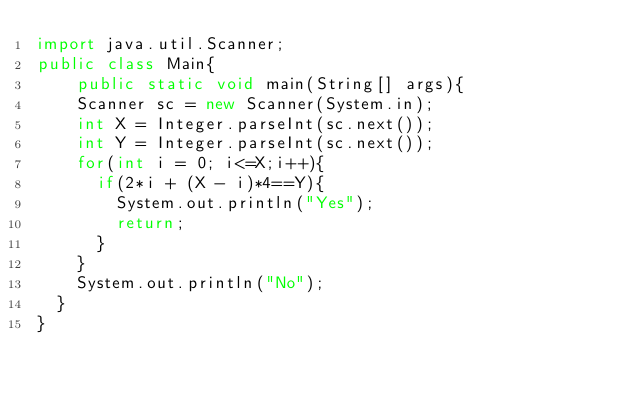<code> <loc_0><loc_0><loc_500><loc_500><_Java_>import java.util.Scanner;
public class Main{
    public static void main(String[] args){
    Scanner sc = new Scanner(System.in);
    int X = Integer.parseInt(sc.next());
    int Y = Integer.parseInt(sc.next());
    for(int i = 0; i<=X;i++){
      if(2*i + (X - i)*4==Y){
        System.out.println("Yes");
        return;
      }
    }
    System.out.println("No");
  }
}</code> 